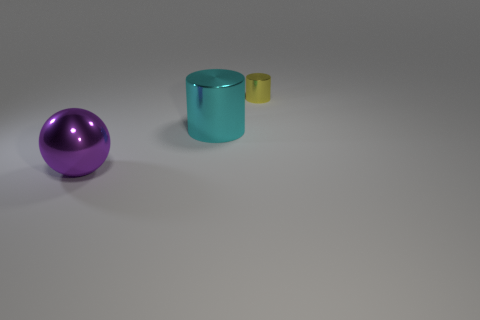What is the shape of the large shiny object behind the large object in front of the large metal cylinder?
Your response must be concise. Cylinder. Is the number of purple objects that are to the left of the metallic sphere less than the number of cyan shiny cylinders?
Your answer should be very brief. Yes. How many shiny cylinders are the same size as the cyan thing?
Provide a short and direct response. 0. There is a object behind the big cyan shiny cylinder; what shape is it?
Provide a succinct answer. Cylinder. Is the number of big blue blocks less than the number of large objects?
Your answer should be very brief. Yes. Are there any other things that are the same color as the small shiny cylinder?
Your answer should be very brief. No. What is the size of the metallic cylinder that is in front of the tiny yellow metallic cylinder?
Make the answer very short. Large. Are there more purple shiny spheres than blue shiny balls?
Your response must be concise. Yes. What is the material of the purple ball?
Offer a very short reply. Metal. How many cylinders are there?
Your answer should be very brief. 2. 